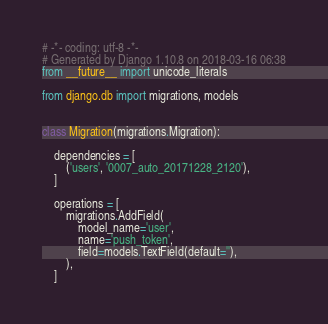<code> <loc_0><loc_0><loc_500><loc_500><_Python_># -*- coding: utf-8 -*-
# Generated by Django 1.10.8 on 2018-03-16 06:38
from __future__ import unicode_literals

from django.db import migrations, models


class Migration(migrations.Migration):

    dependencies = [
        ('users', '0007_auto_20171228_2120'),
    ]

    operations = [
        migrations.AddField(
            model_name='user',
            name='push_token',
            field=models.TextField(default=''),
        ),
    ]
</code> 